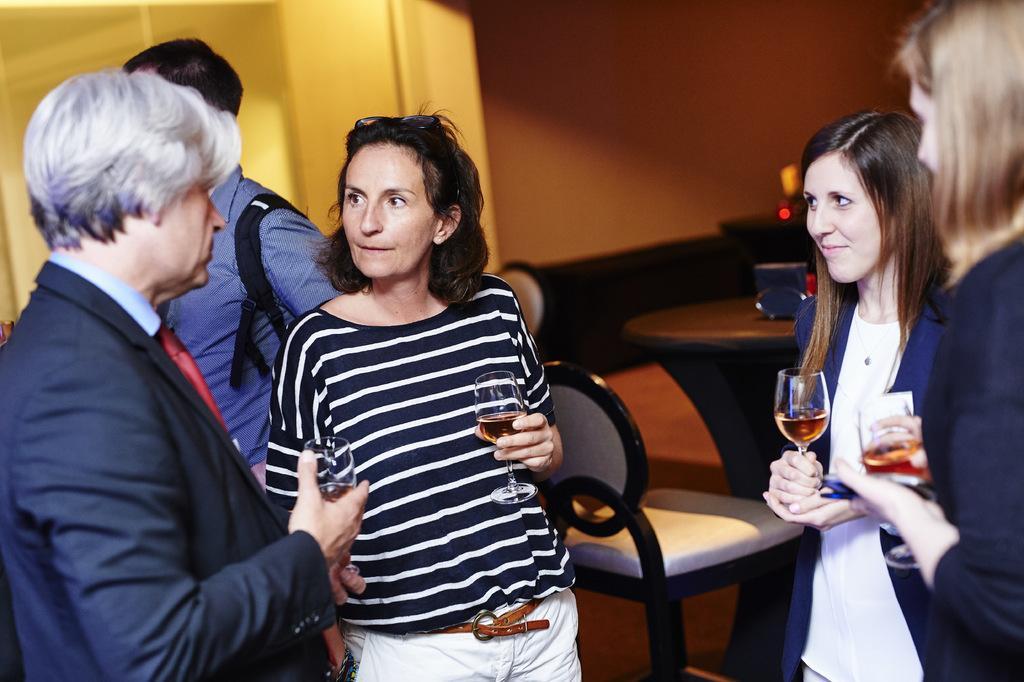Can you describe this image briefly? There are four persons standing. Everyone is holding wine glasses. In the middle a lady wearing a black and white dress is wearing a belt. She is having a goggles. Beside her a person wearing a blue shirt and a bag. There are chair, table. In the background there is wall. 